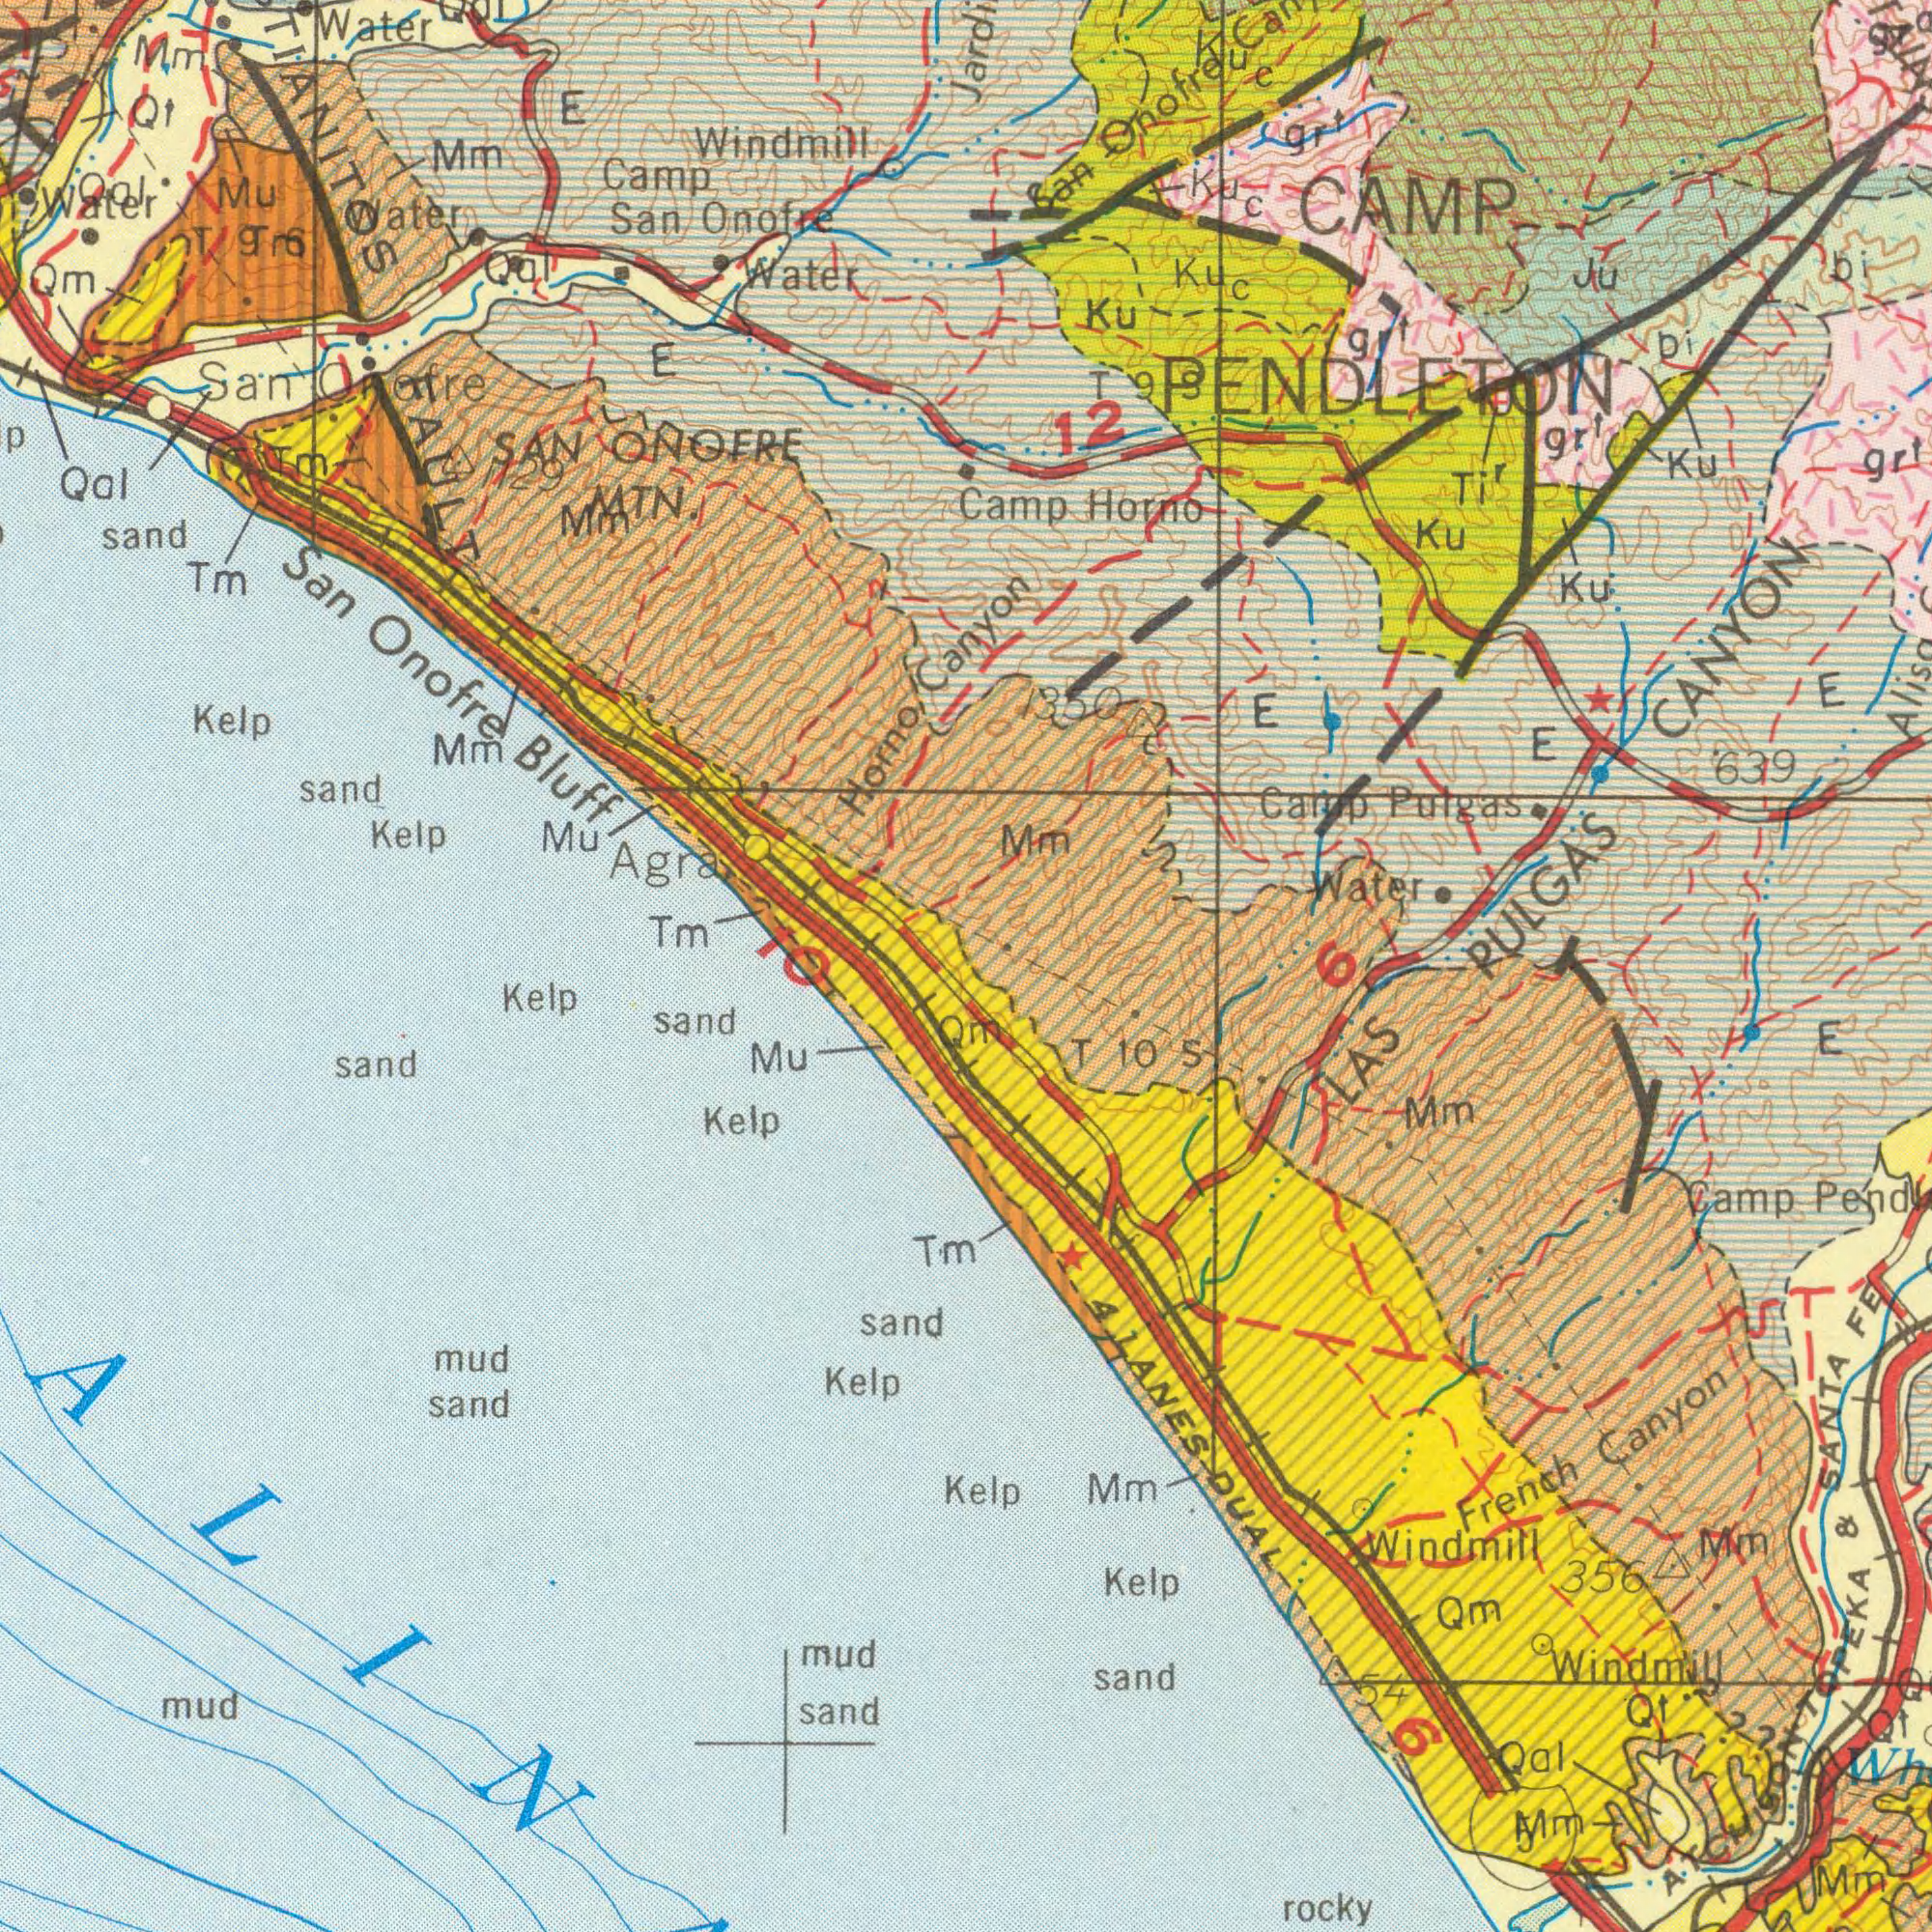What text is shown in the top-right quadrant? Canyon Camp Horno Ku CAMP PENDLETON Ku Ku gr<sup>t</sup> Ku PULGAS CANYON 639 Camp Pulgas gr<sup>t</sup> Water San Onofre Mm C 12 Ti<sup>r</sup> Ju bi E E bi gr<sup>t</sup> Kuc Ku Ku C T99 1350 E 6 gr<sup>t</sup> g What text is shown in the bottom-right quadrant? LAS French Canyon ATCHISON TOPEKA & SANTA FE rocky Camp Kelp sand Mm Mm Windmill Qm Windmill Qt Kelp Mm 5Mm T 10 S Qal Mm 4 LANES DUAL 356 54 6 E Qt 5 ? ? ? What text can you see in the bottom-left section? sand sand sand Kelp Kelp sand Kelp Mu sand mud mud mud Tm Qm What text can you see in the top-left section? San Onofre Bluff Water sand sand Kelp Camp San Onofre Kelp Mu Windmill Qal Water Tm Tm San Onofre Mu SAN ONOFRE MTN. Horno Mm Mm E Water Qal Water E Mm Qt TIANITOS FAULT Agra Qal Qm T9 T6 Mm 1129 Qal Tm 10 